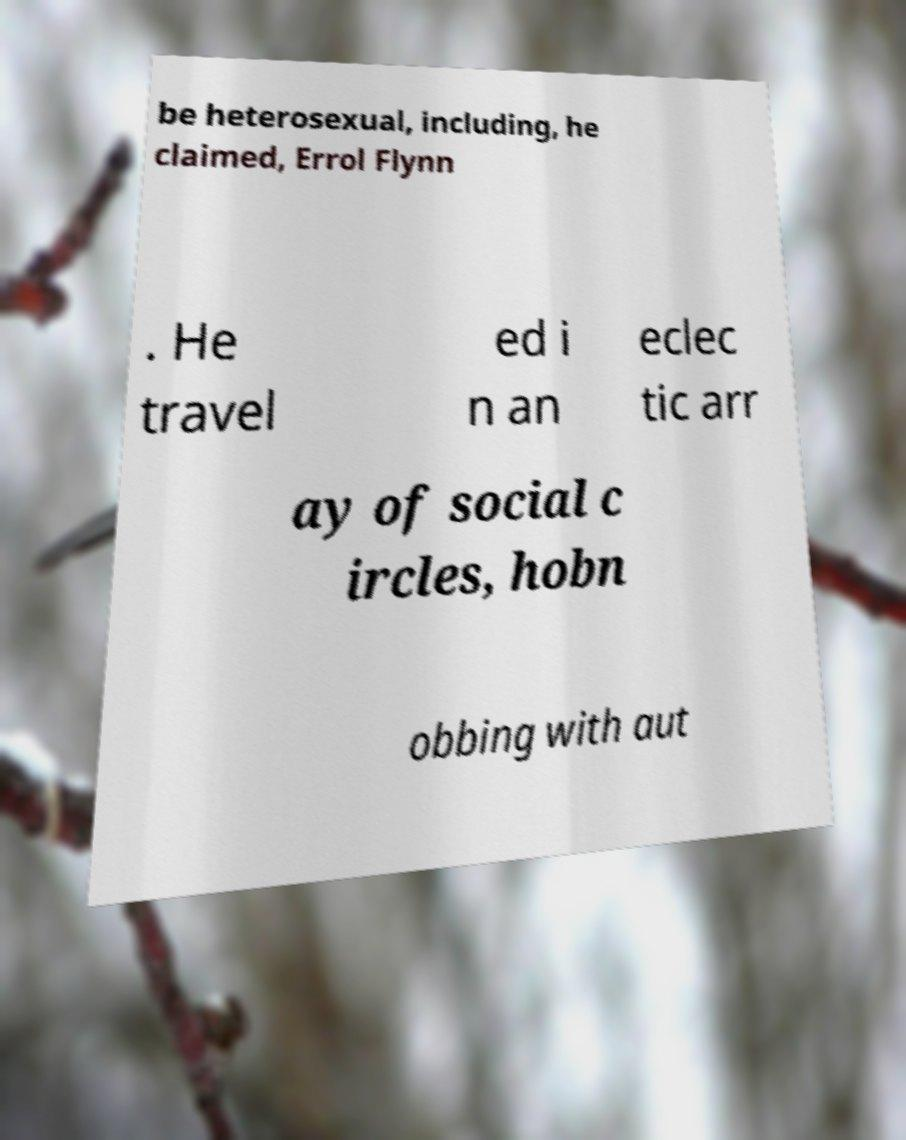Can you accurately transcribe the text from the provided image for me? be heterosexual, including, he claimed, Errol Flynn . He travel ed i n an eclec tic arr ay of social c ircles, hobn obbing with aut 